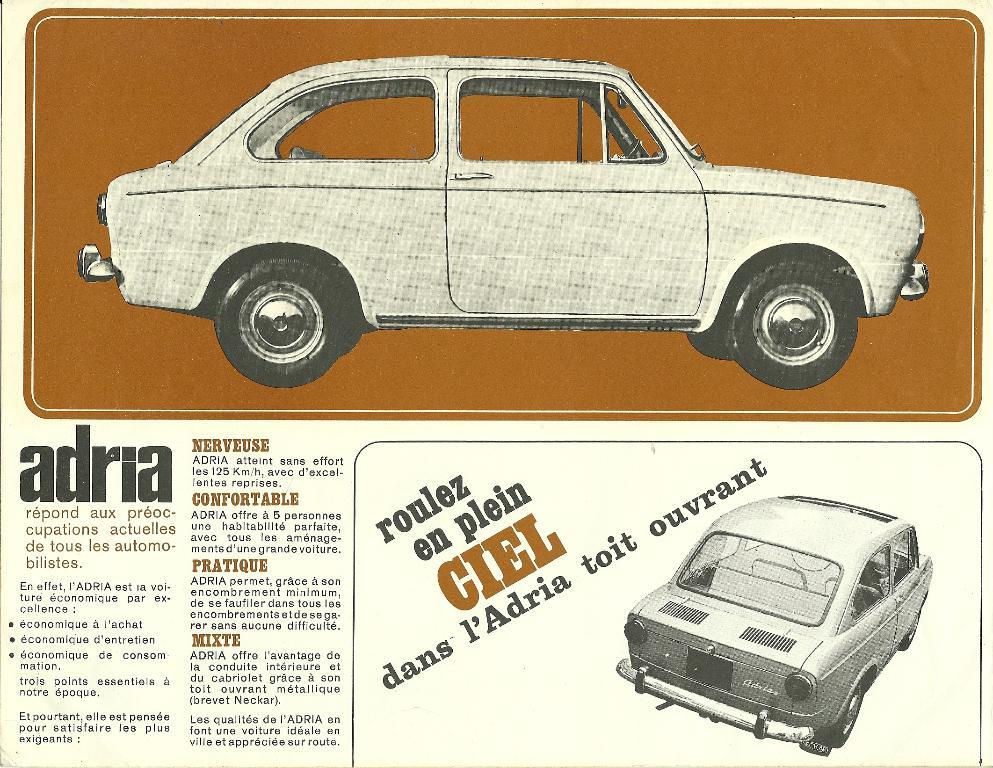What type of vehicles are shown in the image? There are depictions of cars in the image. Can you describe any other elements in the image besides the cars? Yes, there is some text in the image. What type of beam is holding up the cars in the image? There is no beam present in the image; the cars are not being held up by any visible support. 